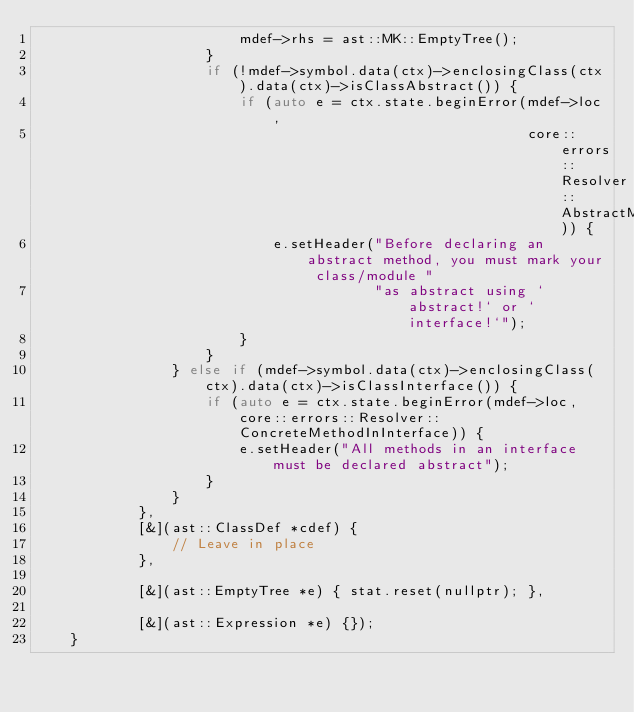<code> <loc_0><loc_0><loc_500><loc_500><_C++_>                        mdef->rhs = ast::MK::EmptyTree();
                    }
                    if (!mdef->symbol.data(ctx)->enclosingClass(ctx).data(ctx)->isClassAbstract()) {
                        if (auto e = ctx.state.beginError(mdef->loc,
                                                          core::errors::Resolver::AbstractMethodOutsideAbstract)) {
                            e.setHeader("Before declaring an abstract method, you must mark your class/module "
                                        "as abstract using `abstract!` or `interface!`");
                        }
                    }
                } else if (mdef->symbol.data(ctx)->enclosingClass(ctx).data(ctx)->isClassInterface()) {
                    if (auto e = ctx.state.beginError(mdef->loc, core::errors::Resolver::ConcreteMethodInInterface)) {
                        e.setHeader("All methods in an interface must be declared abstract");
                    }
                }
            },
            [&](ast::ClassDef *cdef) {
                // Leave in place
            },

            [&](ast::EmptyTree *e) { stat.reset(nullptr); },

            [&](ast::Expression *e) {});
    }
</code> 